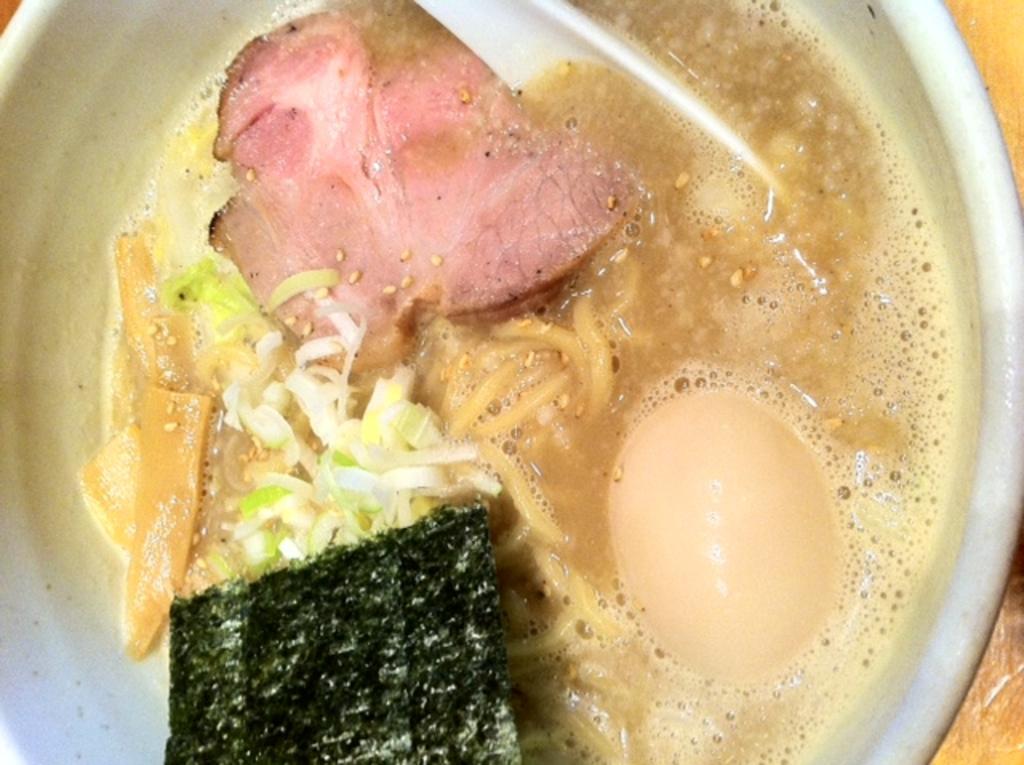Can you describe this image briefly? In this image there is a bowl with a spoon, an egg, soup, noodles, meat and a few things in it and it is kept on the table. 